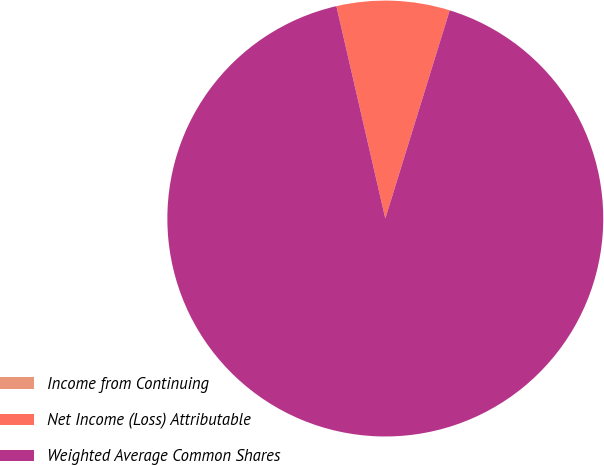Convert chart. <chart><loc_0><loc_0><loc_500><loc_500><pie_chart><fcel>Income from Continuing<fcel>Net Income (Loss) Attributable<fcel>Weighted Average Common Shares<nl><fcel>0.0%<fcel>8.38%<fcel>91.62%<nl></chart> 